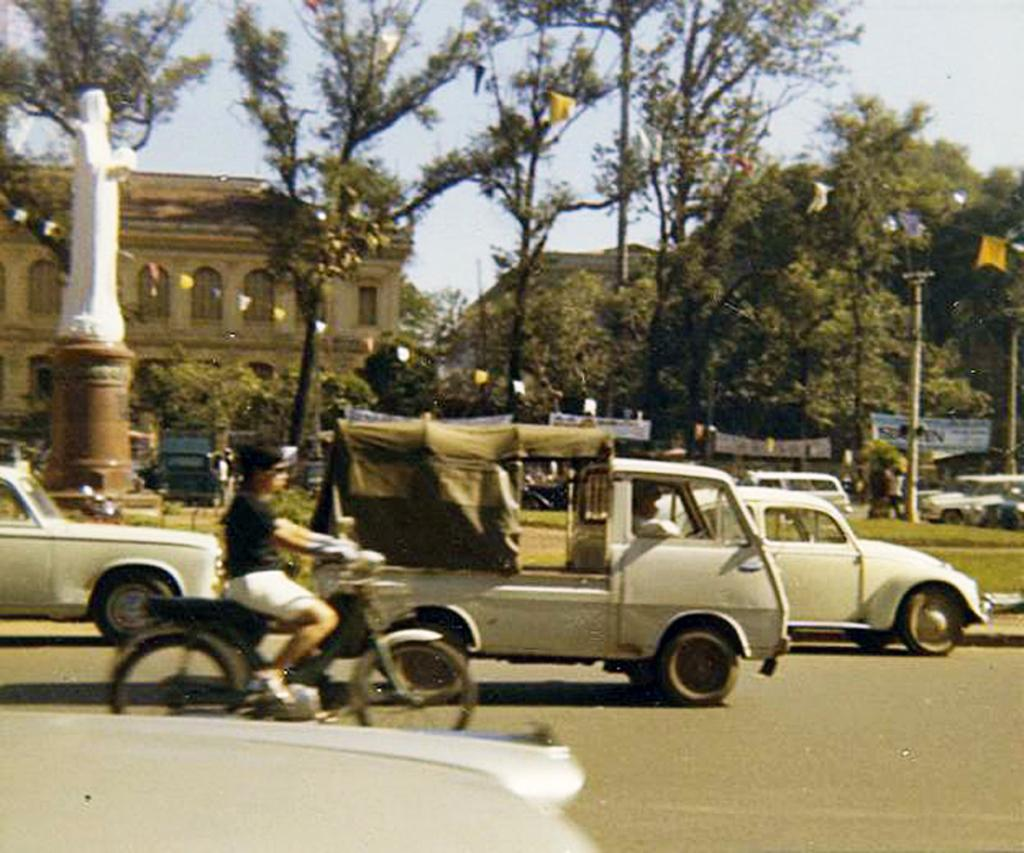What can be seen at the bottom of the image? There is a road at the bottom of the image. What types of vehicles are present in the image? There are many vehicles in the image. What can be seen in the background of the image? There are trees and buildings in the background of the image. What is visible at the top of the image? The sky is visible at the top of the image. Where are the cows grazing in the image? There are no cows present in the image. What type of flight is taking place in the image? There is no flight present in the image; it features vehicles on a road with a background of trees, buildings, and sky. 